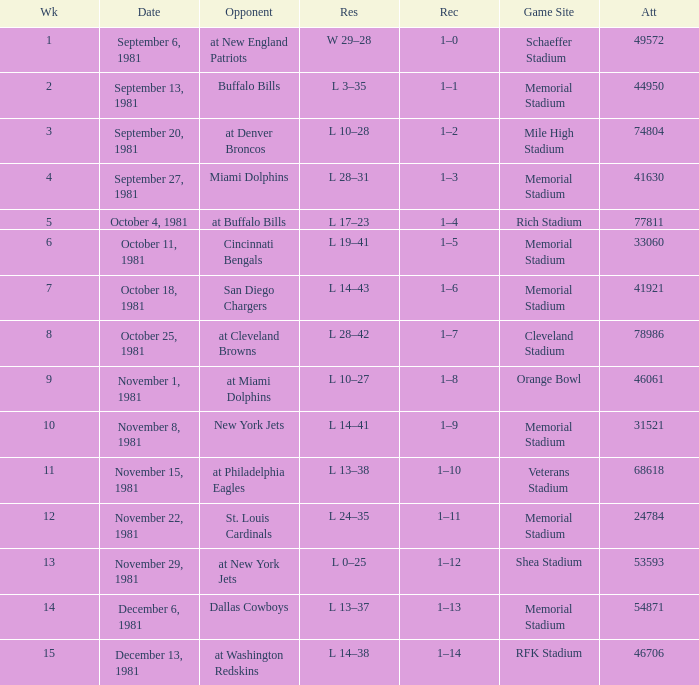When it is October 25, 1981 who is the opponent? At cleveland browns. 